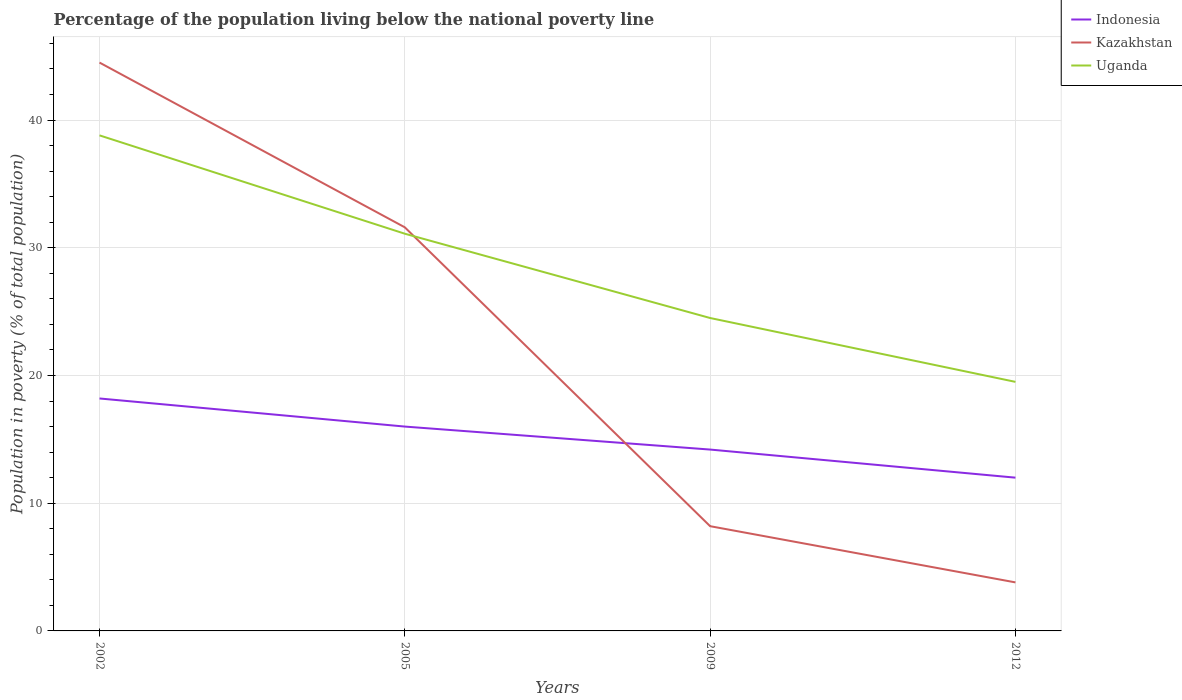Does the line corresponding to Indonesia intersect with the line corresponding to Uganda?
Offer a terse response. No. Across all years, what is the maximum percentage of the population living below the national poverty line in Indonesia?
Give a very brief answer. 12. What is the total percentage of the population living below the national poverty line in Uganda in the graph?
Ensure brevity in your answer.  14.3. What is the difference between the highest and the second highest percentage of the population living below the national poverty line in Kazakhstan?
Keep it short and to the point. 40.7. What is the title of the graph?
Provide a succinct answer. Percentage of the population living below the national poverty line. Does "Uzbekistan" appear as one of the legend labels in the graph?
Provide a short and direct response. No. What is the label or title of the X-axis?
Give a very brief answer. Years. What is the label or title of the Y-axis?
Keep it short and to the point. Population in poverty (% of total population). What is the Population in poverty (% of total population) in Indonesia in 2002?
Provide a short and direct response. 18.2. What is the Population in poverty (% of total population) in Kazakhstan in 2002?
Provide a succinct answer. 44.5. What is the Population in poverty (% of total population) in Uganda in 2002?
Keep it short and to the point. 38.8. What is the Population in poverty (% of total population) in Indonesia in 2005?
Provide a succinct answer. 16. What is the Population in poverty (% of total population) in Kazakhstan in 2005?
Make the answer very short. 31.6. What is the Population in poverty (% of total population) in Uganda in 2005?
Make the answer very short. 31.1. What is the Population in poverty (% of total population) in Indonesia in 2009?
Your answer should be compact. 14.2. What is the Population in poverty (% of total population) of Kazakhstan in 2012?
Provide a short and direct response. 3.8. Across all years, what is the maximum Population in poverty (% of total population) of Kazakhstan?
Your response must be concise. 44.5. Across all years, what is the maximum Population in poverty (% of total population) in Uganda?
Make the answer very short. 38.8. What is the total Population in poverty (% of total population) in Indonesia in the graph?
Your response must be concise. 60.4. What is the total Population in poverty (% of total population) of Kazakhstan in the graph?
Ensure brevity in your answer.  88.1. What is the total Population in poverty (% of total population) in Uganda in the graph?
Keep it short and to the point. 113.9. What is the difference between the Population in poverty (% of total population) of Indonesia in 2002 and that in 2005?
Make the answer very short. 2.2. What is the difference between the Population in poverty (% of total population) of Uganda in 2002 and that in 2005?
Keep it short and to the point. 7.7. What is the difference between the Population in poverty (% of total population) of Indonesia in 2002 and that in 2009?
Keep it short and to the point. 4. What is the difference between the Population in poverty (% of total population) in Kazakhstan in 2002 and that in 2009?
Offer a terse response. 36.3. What is the difference between the Population in poverty (% of total population) in Kazakhstan in 2002 and that in 2012?
Your answer should be compact. 40.7. What is the difference between the Population in poverty (% of total population) of Uganda in 2002 and that in 2012?
Your answer should be compact. 19.3. What is the difference between the Population in poverty (% of total population) in Indonesia in 2005 and that in 2009?
Your response must be concise. 1.8. What is the difference between the Population in poverty (% of total population) in Kazakhstan in 2005 and that in 2009?
Your answer should be very brief. 23.4. What is the difference between the Population in poverty (% of total population) in Uganda in 2005 and that in 2009?
Provide a succinct answer. 6.6. What is the difference between the Population in poverty (% of total population) in Indonesia in 2005 and that in 2012?
Give a very brief answer. 4. What is the difference between the Population in poverty (% of total population) in Kazakhstan in 2005 and that in 2012?
Make the answer very short. 27.8. What is the difference between the Population in poverty (% of total population) of Indonesia in 2009 and that in 2012?
Offer a very short reply. 2.2. What is the difference between the Population in poverty (% of total population) of Uganda in 2009 and that in 2012?
Provide a short and direct response. 5. What is the difference between the Population in poverty (% of total population) of Indonesia in 2002 and the Population in poverty (% of total population) of Uganda in 2005?
Offer a very short reply. -12.9. What is the difference between the Population in poverty (% of total population) of Kazakhstan in 2002 and the Population in poverty (% of total population) of Uganda in 2005?
Your response must be concise. 13.4. What is the difference between the Population in poverty (% of total population) of Indonesia in 2002 and the Population in poverty (% of total population) of Uganda in 2009?
Your answer should be compact. -6.3. What is the difference between the Population in poverty (% of total population) of Indonesia in 2002 and the Population in poverty (% of total population) of Kazakhstan in 2012?
Your answer should be very brief. 14.4. What is the difference between the Population in poverty (% of total population) in Indonesia in 2005 and the Population in poverty (% of total population) in Kazakhstan in 2009?
Your answer should be very brief. 7.8. What is the difference between the Population in poverty (% of total population) of Indonesia in 2005 and the Population in poverty (% of total population) of Uganda in 2012?
Keep it short and to the point. -3.5. What is the difference between the Population in poverty (% of total population) of Kazakhstan in 2005 and the Population in poverty (% of total population) of Uganda in 2012?
Your response must be concise. 12.1. What is the difference between the Population in poverty (% of total population) of Indonesia in 2009 and the Population in poverty (% of total population) of Uganda in 2012?
Your response must be concise. -5.3. What is the difference between the Population in poverty (% of total population) in Kazakhstan in 2009 and the Population in poverty (% of total population) in Uganda in 2012?
Ensure brevity in your answer.  -11.3. What is the average Population in poverty (% of total population) in Kazakhstan per year?
Ensure brevity in your answer.  22.02. What is the average Population in poverty (% of total population) of Uganda per year?
Offer a terse response. 28.48. In the year 2002, what is the difference between the Population in poverty (% of total population) in Indonesia and Population in poverty (% of total population) in Kazakhstan?
Provide a short and direct response. -26.3. In the year 2002, what is the difference between the Population in poverty (% of total population) of Indonesia and Population in poverty (% of total population) of Uganda?
Provide a short and direct response. -20.6. In the year 2005, what is the difference between the Population in poverty (% of total population) in Indonesia and Population in poverty (% of total population) in Kazakhstan?
Your response must be concise. -15.6. In the year 2005, what is the difference between the Population in poverty (% of total population) in Indonesia and Population in poverty (% of total population) in Uganda?
Provide a short and direct response. -15.1. In the year 2009, what is the difference between the Population in poverty (% of total population) in Indonesia and Population in poverty (% of total population) in Uganda?
Your answer should be very brief. -10.3. In the year 2009, what is the difference between the Population in poverty (% of total population) of Kazakhstan and Population in poverty (% of total population) of Uganda?
Offer a very short reply. -16.3. In the year 2012, what is the difference between the Population in poverty (% of total population) of Indonesia and Population in poverty (% of total population) of Kazakhstan?
Give a very brief answer. 8.2. In the year 2012, what is the difference between the Population in poverty (% of total population) of Indonesia and Population in poverty (% of total population) of Uganda?
Keep it short and to the point. -7.5. In the year 2012, what is the difference between the Population in poverty (% of total population) in Kazakhstan and Population in poverty (% of total population) in Uganda?
Provide a succinct answer. -15.7. What is the ratio of the Population in poverty (% of total population) of Indonesia in 2002 to that in 2005?
Offer a very short reply. 1.14. What is the ratio of the Population in poverty (% of total population) in Kazakhstan in 2002 to that in 2005?
Your answer should be very brief. 1.41. What is the ratio of the Population in poverty (% of total population) in Uganda in 2002 to that in 2005?
Provide a succinct answer. 1.25. What is the ratio of the Population in poverty (% of total population) of Indonesia in 2002 to that in 2009?
Offer a very short reply. 1.28. What is the ratio of the Population in poverty (% of total population) in Kazakhstan in 2002 to that in 2009?
Ensure brevity in your answer.  5.43. What is the ratio of the Population in poverty (% of total population) in Uganda in 2002 to that in 2009?
Provide a succinct answer. 1.58. What is the ratio of the Population in poverty (% of total population) of Indonesia in 2002 to that in 2012?
Give a very brief answer. 1.52. What is the ratio of the Population in poverty (% of total population) in Kazakhstan in 2002 to that in 2012?
Your answer should be very brief. 11.71. What is the ratio of the Population in poverty (% of total population) in Uganda in 2002 to that in 2012?
Offer a very short reply. 1.99. What is the ratio of the Population in poverty (% of total population) of Indonesia in 2005 to that in 2009?
Give a very brief answer. 1.13. What is the ratio of the Population in poverty (% of total population) of Kazakhstan in 2005 to that in 2009?
Your answer should be compact. 3.85. What is the ratio of the Population in poverty (% of total population) of Uganda in 2005 to that in 2009?
Your answer should be very brief. 1.27. What is the ratio of the Population in poverty (% of total population) in Indonesia in 2005 to that in 2012?
Offer a terse response. 1.33. What is the ratio of the Population in poverty (% of total population) of Kazakhstan in 2005 to that in 2012?
Give a very brief answer. 8.32. What is the ratio of the Population in poverty (% of total population) of Uganda in 2005 to that in 2012?
Your answer should be very brief. 1.59. What is the ratio of the Population in poverty (% of total population) in Indonesia in 2009 to that in 2012?
Give a very brief answer. 1.18. What is the ratio of the Population in poverty (% of total population) of Kazakhstan in 2009 to that in 2012?
Your answer should be compact. 2.16. What is the ratio of the Population in poverty (% of total population) in Uganda in 2009 to that in 2012?
Offer a terse response. 1.26. What is the difference between the highest and the second highest Population in poverty (% of total population) of Kazakhstan?
Keep it short and to the point. 12.9. What is the difference between the highest and the lowest Population in poverty (% of total population) in Kazakhstan?
Provide a short and direct response. 40.7. What is the difference between the highest and the lowest Population in poverty (% of total population) in Uganda?
Your answer should be very brief. 19.3. 